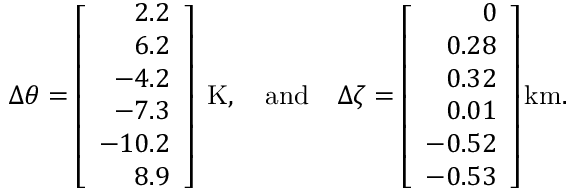<formula> <loc_0><loc_0><loc_500><loc_500>{ \Delta \theta } = \left [ \begin{array} { r } { 2 . 2 } \\ { 6 . 2 } \\ { - 4 . 2 } \\ { - 7 . 3 } \\ { - 1 0 . 2 } \\ { 8 . 9 } \end{array} \right ] K , \quad a n d \quad \Delta \zeta = \left [ \begin{array} { r } { 0 } \\ { 0 . 2 8 } \\ { 0 . 3 2 } \\ { 0 . 0 1 } \\ { - 0 . 5 2 } \\ { - 0 . 5 3 } \end{array} \right ] k m .</formula> 